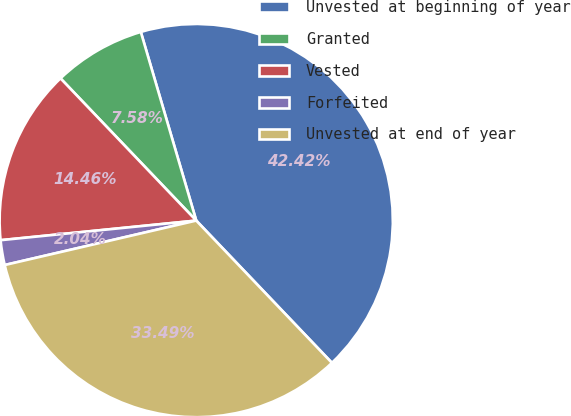Convert chart to OTSL. <chart><loc_0><loc_0><loc_500><loc_500><pie_chart><fcel>Unvested at beginning of year<fcel>Granted<fcel>Vested<fcel>Forfeited<fcel>Unvested at end of year<nl><fcel>42.42%<fcel>7.58%<fcel>14.46%<fcel>2.04%<fcel>33.49%<nl></chart> 